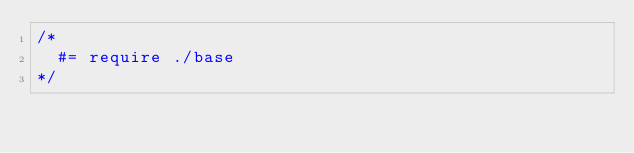Convert code to text. <code><loc_0><loc_0><loc_500><loc_500><_CSS_>/*
  #= require ./base
*/</code> 